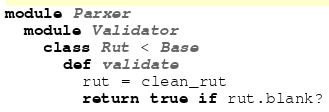Convert code to text. <code><loc_0><loc_0><loc_500><loc_500><_Ruby_>module Parxer
  module Validator
    class Rut < Base
      def validate
        rut = clean_rut
        return true if rut.blank?</code> 